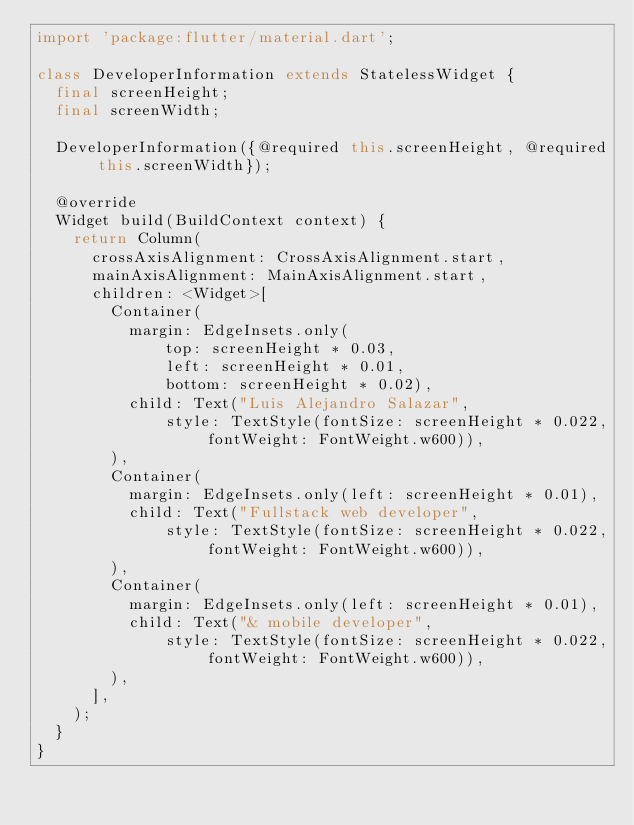Convert code to text. <code><loc_0><loc_0><loc_500><loc_500><_Dart_>import 'package:flutter/material.dart';

class DeveloperInformation extends StatelessWidget {
  final screenHeight;
  final screenWidth;

  DeveloperInformation({@required this.screenHeight, @required this.screenWidth});

  @override
  Widget build(BuildContext context) {
    return Column(
      crossAxisAlignment: CrossAxisAlignment.start,
      mainAxisAlignment: MainAxisAlignment.start,
      children: <Widget>[
        Container(
          margin: EdgeInsets.only(
              top: screenHeight * 0.03,
              left: screenHeight * 0.01,
              bottom: screenHeight * 0.02),
          child: Text("Luis Alejandro Salazar",
              style: TextStyle(fontSize: screenHeight * 0.022, fontWeight: FontWeight.w600)),
        ),
        Container(
          margin: EdgeInsets.only(left: screenHeight * 0.01),
          child: Text("Fullstack web developer",
              style: TextStyle(fontSize: screenHeight * 0.022, fontWeight: FontWeight.w600)),
        ),
        Container(
          margin: EdgeInsets.only(left: screenHeight * 0.01),
          child: Text("& mobile developer",
              style: TextStyle(fontSize: screenHeight * 0.022, fontWeight: FontWeight.w600)),
        ),
      ],
    );
  }
}
</code> 